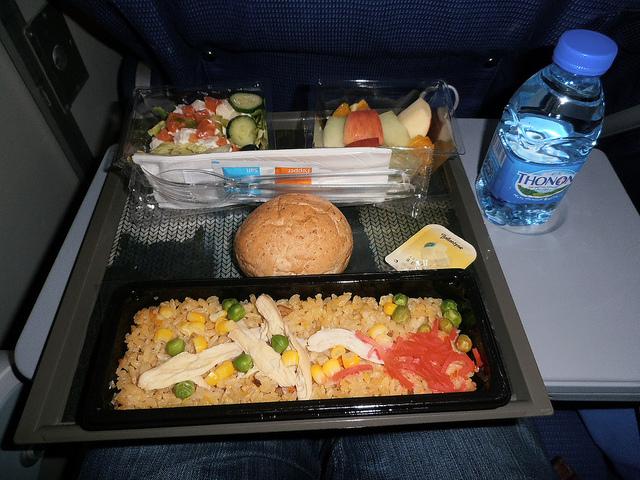What is the drink in this picture?
Answer briefly. Water. Is this a meal tray in a plane?
Answer briefly. Yes. What color are the plates?
Write a very short answer. Black. Is there fruit in this meal?
Short answer required. Yes. 